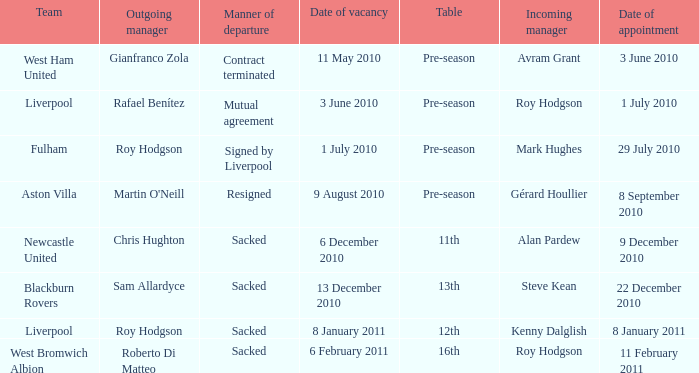What is the date of vacancy for the Liverpool team with a table named pre-season? 3 June 2010. 